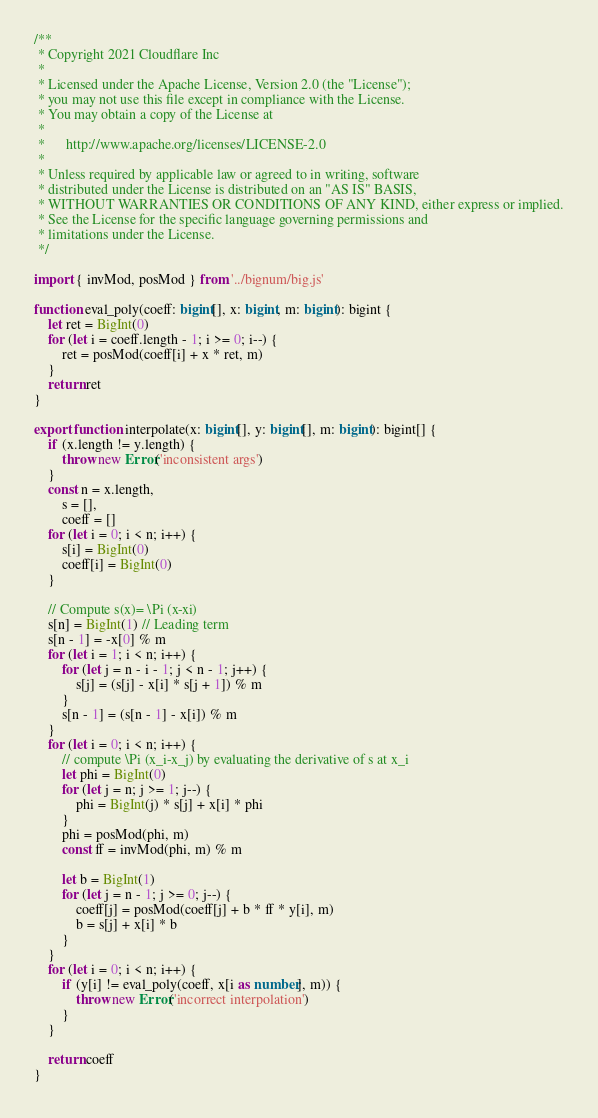<code> <loc_0><loc_0><loc_500><loc_500><_TypeScript_>/**
 * Copyright 2021 Cloudflare Inc
 *
 * Licensed under the Apache License, Version 2.0 (the "License");
 * you may not use this file except in compliance with the License.
 * You may obtain a copy of the License at
 *
 *      http://www.apache.org/licenses/LICENSE-2.0
 *
 * Unless required by applicable law or agreed to in writing, software
 * distributed under the License is distributed on an "AS IS" BASIS,
 * WITHOUT WARRANTIES OR CONDITIONS OF ANY KIND, either express or implied.
 * See the License for the specific language governing permissions and
 * limitations under the License.
 */

import { invMod, posMod } from '../bignum/big.js'

function eval_poly(coeff: bigint[], x: bigint, m: bigint): bigint {
    let ret = BigInt(0)
    for (let i = coeff.length - 1; i >= 0; i--) {
        ret = posMod(coeff[i] + x * ret, m)
    }
    return ret
}

export function interpolate(x: bigint[], y: bigint[], m: bigint): bigint[] {
    if (x.length != y.length) {
        throw new Error('inconsistent args')
    }
    const n = x.length,
        s = [],
        coeff = []
    for (let i = 0; i < n; i++) {
        s[i] = BigInt(0)
        coeff[i] = BigInt(0)
    }

    // Compute s(x)= \Pi (x-xi)
    s[n] = BigInt(1) // Leading term
    s[n - 1] = -x[0] % m
    for (let i = 1; i < n; i++) {
        for (let j = n - i - 1; j < n - 1; j++) {
            s[j] = (s[j] - x[i] * s[j + 1]) % m
        }
        s[n - 1] = (s[n - 1] - x[i]) % m
    }
    for (let i = 0; i < n; i++) {
        // compute \Pi (x_i-x_j) by evaluating the derivative of s at x_i
        let phi = BigInt(0)
        for (let j = n; j >= 1; j--) {
            phi = BigInt(j) * s[j] + x[i] * phi
        }
        phi = posMod(phi, m)
        const ff = invMod(phi, m) % m

        let b = BigInt(1)
        for (let j = n - 1; j >= 0; j--) {
            coeff[j] = posMod(coeff[j] + b * ff * y[i], m)
            b = s[j] + x[i] * b
        }
    }
    for (let i = 0; i < n; i++) {
        if (y[i] != eval_poly(coeff, x[i as number], m)) {
            throw new Error('incorrect interpolation')
        }
    }

    return coeff
}
</code> 